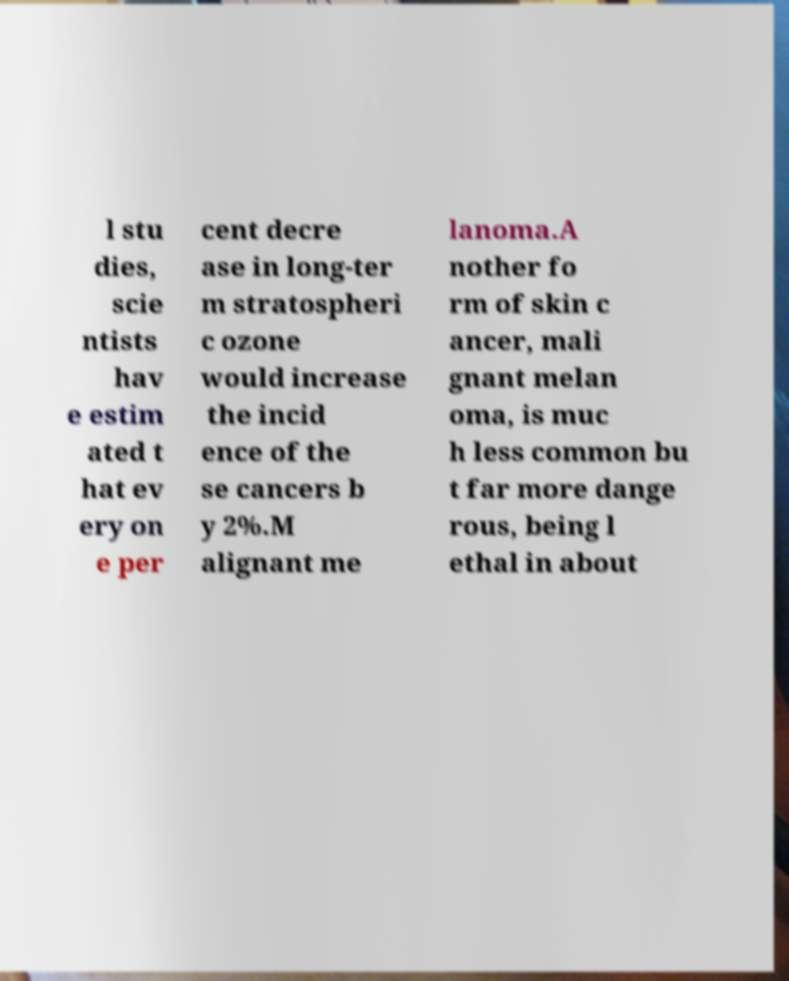Please read and relay the text visible in this image. What does it say? l stu dies, scie ntists hav e estim ated t hat ev ery on e per cent decre ase in long-ter m stratospheri c ozone would increase the incid ence of the se cancers b y 2%.M alignant me lanoma.A nother fo rm of skin c ancer, mali gnant melan oma, is muc h less common bu t far more dange rous, being l ethal in about 